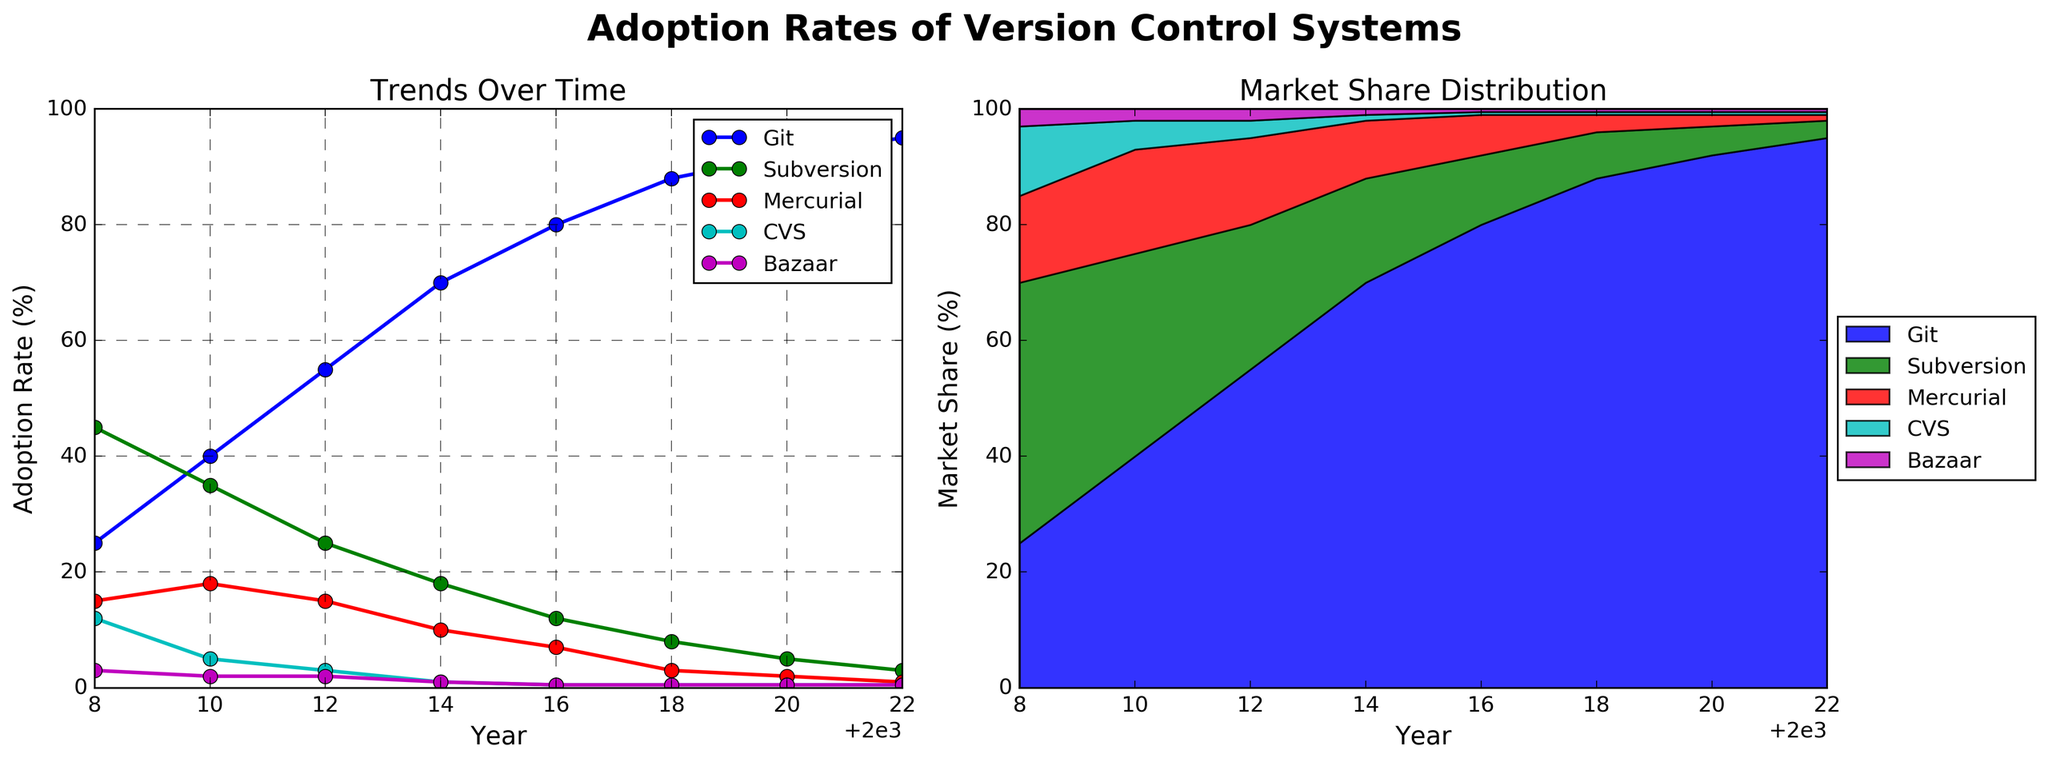What year did Git surpass Subversion in adoption rate? By looking at the plot, identify the year where the line for Git crosses above the line for Subversion.
Answer: 2010 What was the adoption rate difference between Git and Subversion in 2016? From the line plot, find the adoption percentages for Git and Subversion in 2016, then subtract the adoption rate of Subversion from that of Git.
Answer: 68 In which year did CVS and Bazaar both reach their minimum adoption rates? Look at the line plot and find the year when both CVS and Bazaar reached their lowest points, which is 0.5%.
Answer: 2016 What's the difference in Git's adoption rate between 2008 and 2022? Identify Git's adoption percentages in 2008 and 2022 from the plot and subtract the 2008 value from the 2022 value.
Answer: 70 Which version control system had the least adoption rate in 2012 and by how much? From the line plot, find the lowest adoption rate in 2012 and identify the associated version control system.
Answer: Bazaar, 2% Between 2008 and 2022, which version control system's adoption rate trend is consistently decreasing? Observe the line plot for trends over time and identify the version control system that shows a consistent decline.
Answer: Subversion What is the average adoption rate of Mercurial from 2008 to 2022? Sum the adoption rates of Mercurial for each year and divide it by the number of years.
Answer: 8.88 How did the market share distribution of version control systems change between 2008 and 2022? Compare the stacked area plot sections for all version control systems in 2008 and 2022 to understand how their shares changed.
Answer: Git increased, others decreased During which year did Git have the largest single-year increase in adoption rate? Identify the year in the line plot where the slope for Git is the steepest.
Answer: 2014 What is the total adoption percentage for all version control systems in the year 2010? Add up the adoption rates of all the version control systems in 2010 from the plot.
Answer: 100 